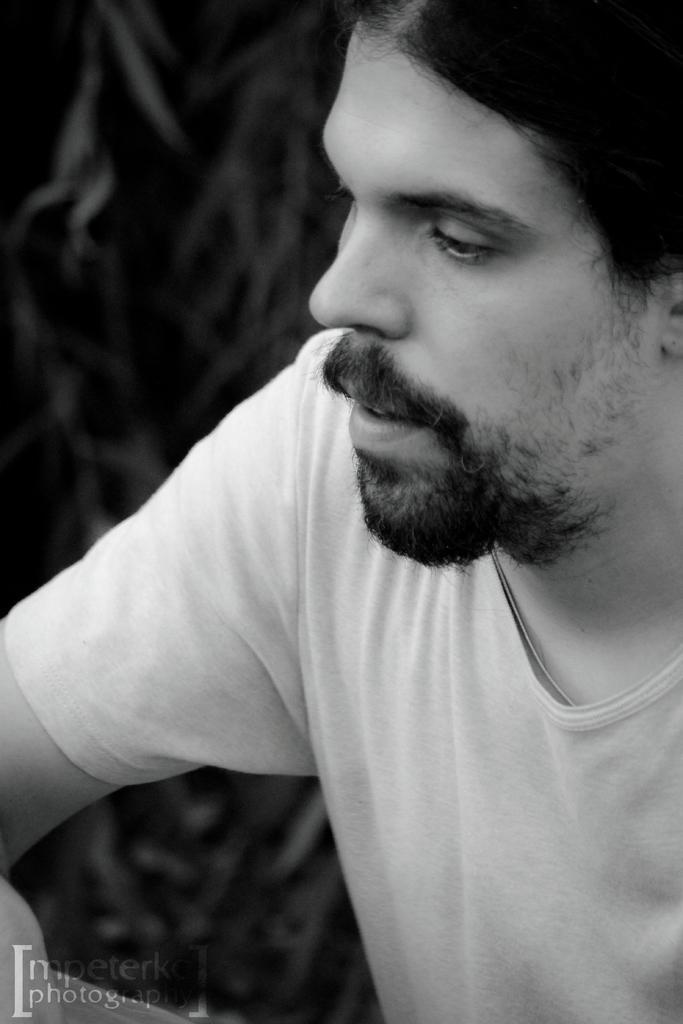In one or two sentences, can you explain what this image depicts? In this picture I can observe a man in the middle of the picture. The background is blurred. In the bottom left side I can observe watermark. 